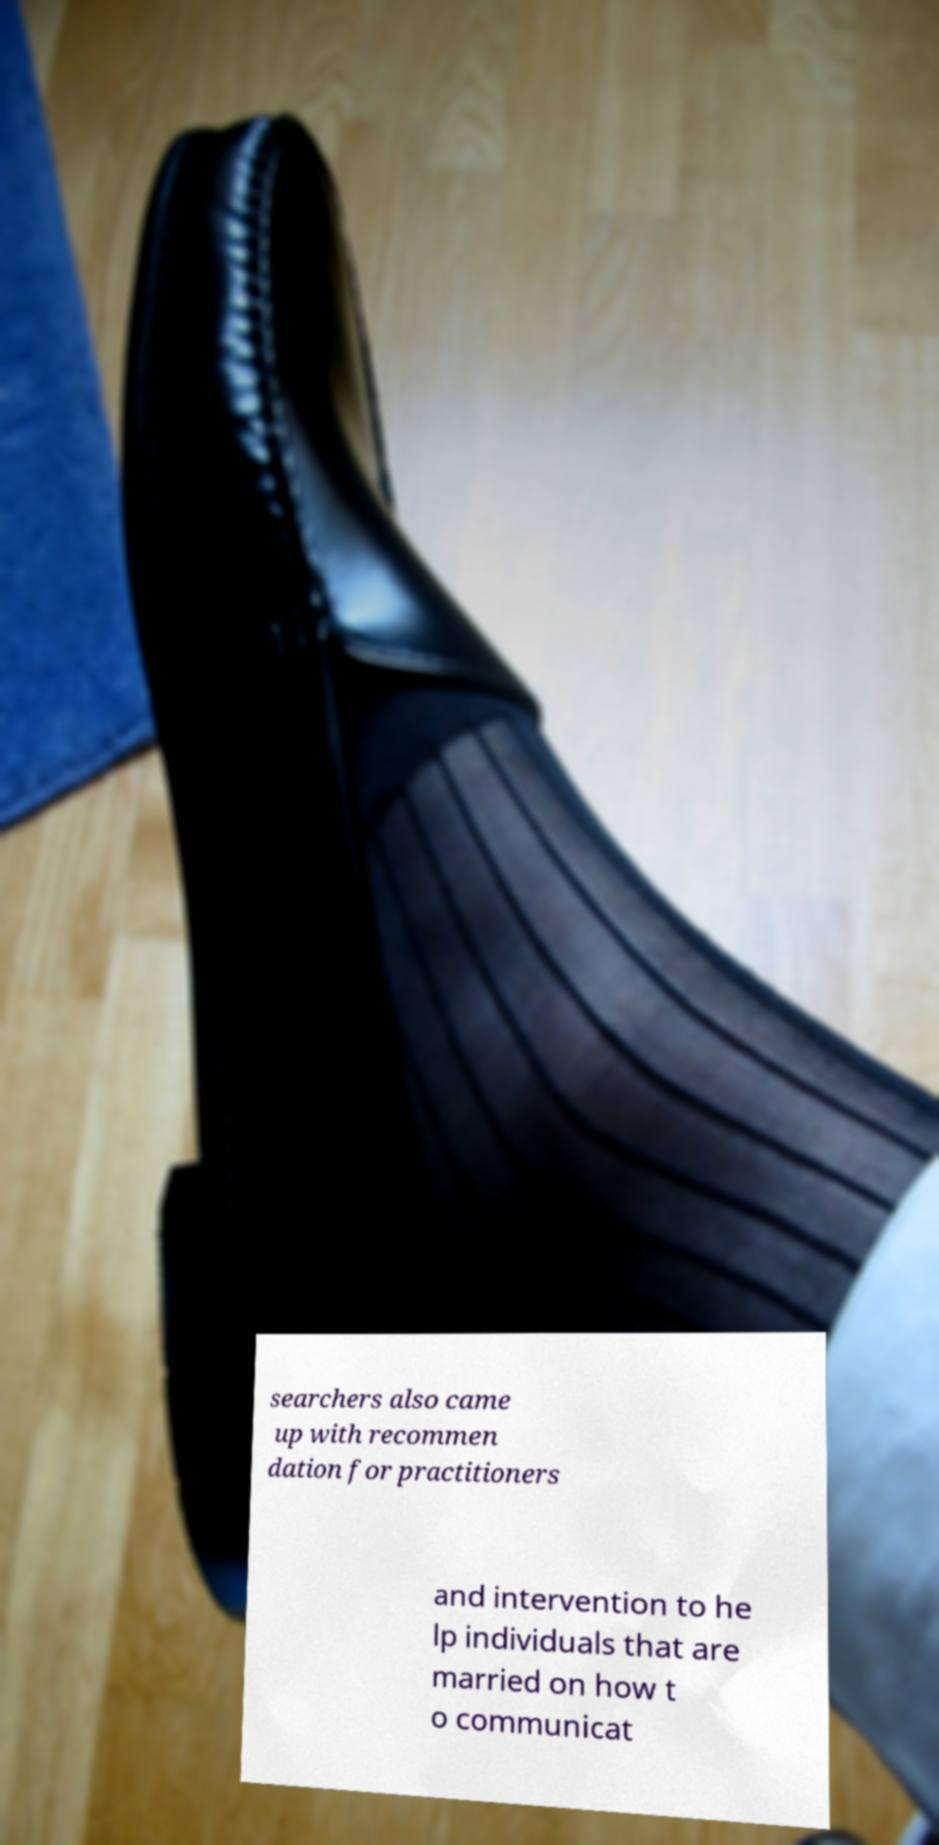Can you read and provide the text displayed in the image?This photo seems to have some interesting text. Can you extract and type it out for me? searchers also came up with recommen dation for practitioners and intervention to he lp individuals that are married on how t o communicat 